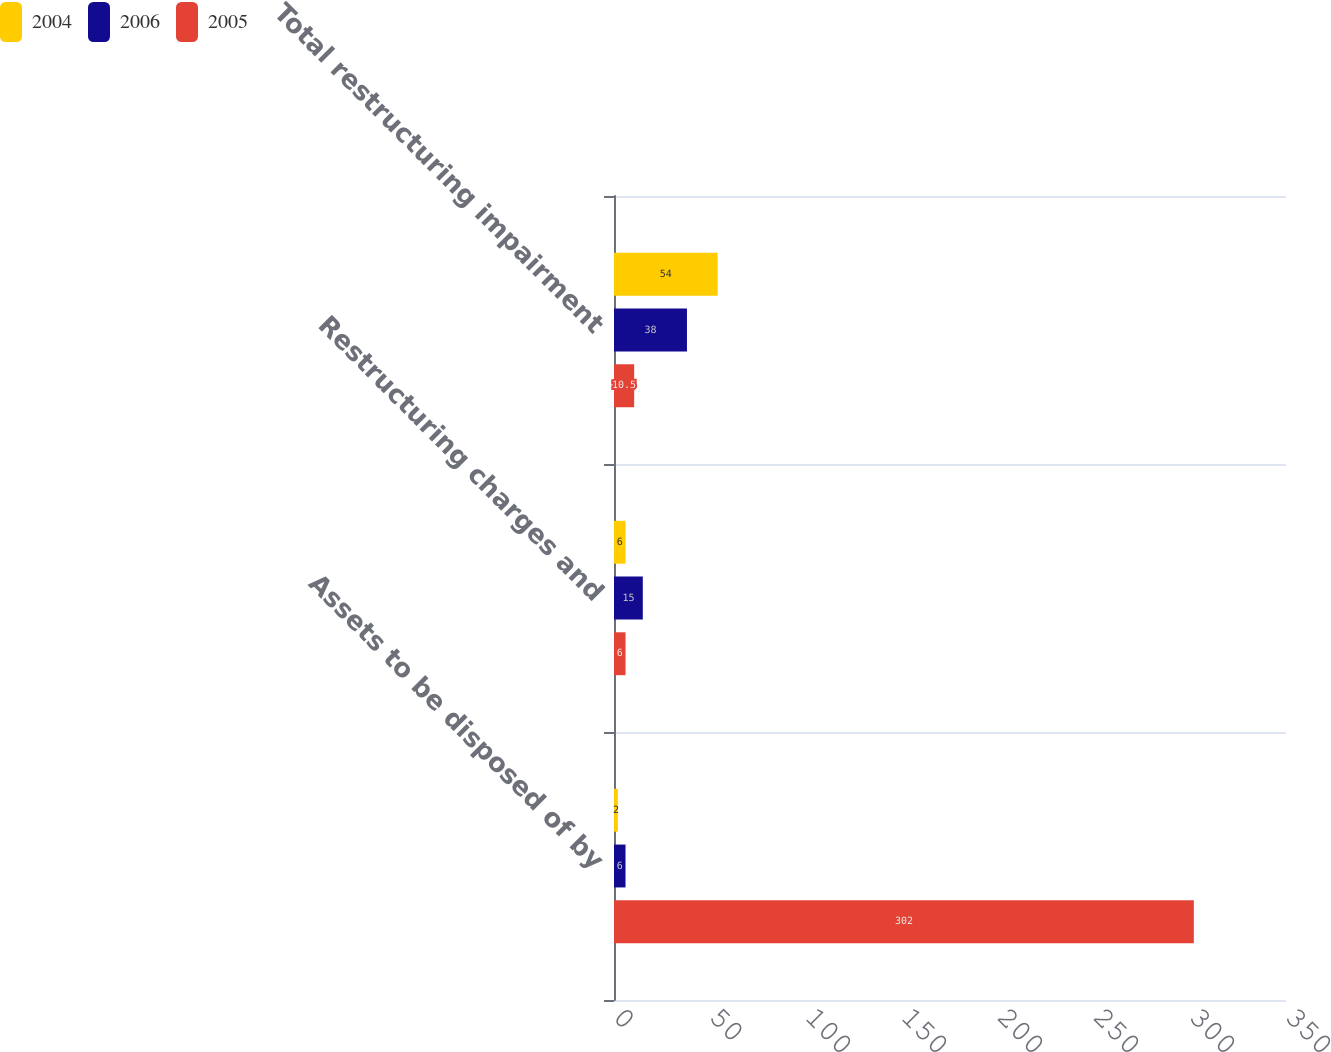Convert chart to OTSL. <chart><loc_0><loc_0><loc_500><loc_500><stacked_bar_chart><ecel><fcel>Assets to be disposed of by<fcel>Restructuring charges and<fcel>Total restructuring impairment<nl><fcel>2004<fcel>2<fcel>6<fcel>54<nl><fcel>2006<fcel>6<fcel>15<fcel>38<nl><fcel>2005<fcel>302<fcel>6<fcel>10.5<nl></chart> 